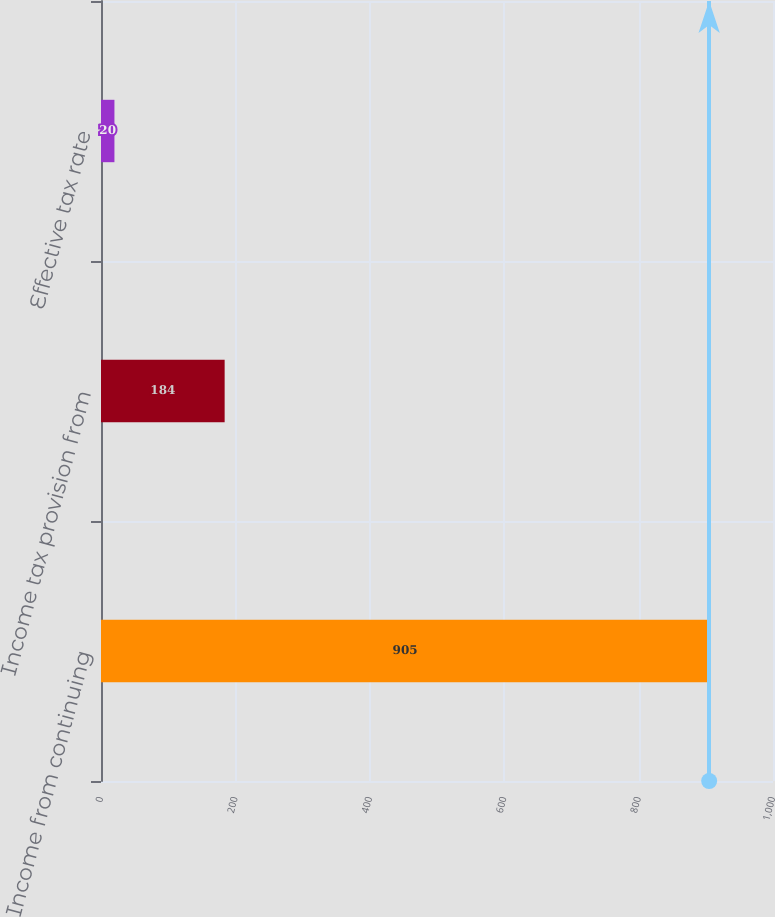<chart> <loc_0><loc_0><loc_500><loc_500><bar_chart><fcel>Income from continuing<fcel>Income tax provision from<fcel>Effective tax rate<nl><fcel>905<fcel>184<fcel>20<nl></chart> 